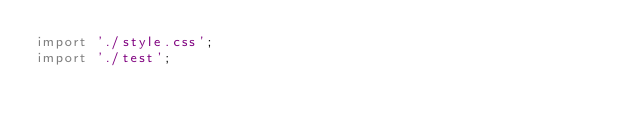Convert code to text. <code><loc_0><loc_0><loc_500><loc_500><_JavaScript_>import './style.css';
import './test';



</code> 